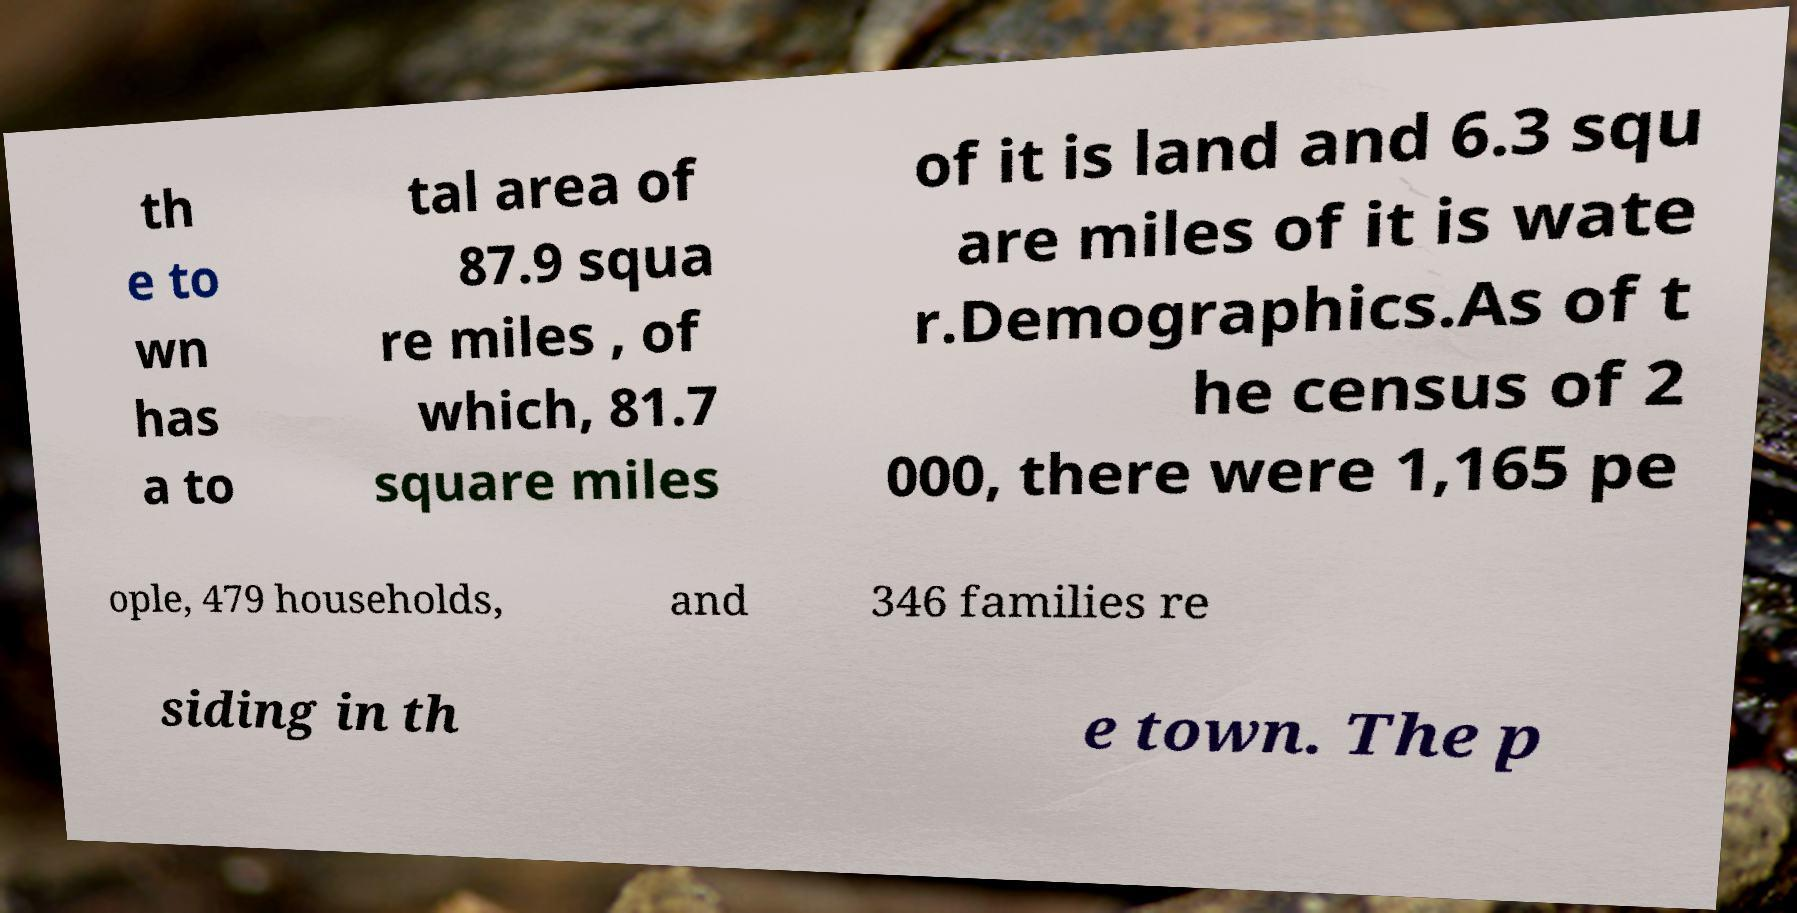Please read and relay the text visible in this image. What does it say? th e to wn has a to tal area of 87.9 squa re miles , of which, 81.7 square miles of it is land and 6.3 squ are miles of it is wate r.Demographics.As of t he census of 2 000, there were 1,165 pe ople, 479 households, and 346 families re siding in th e town. The p 